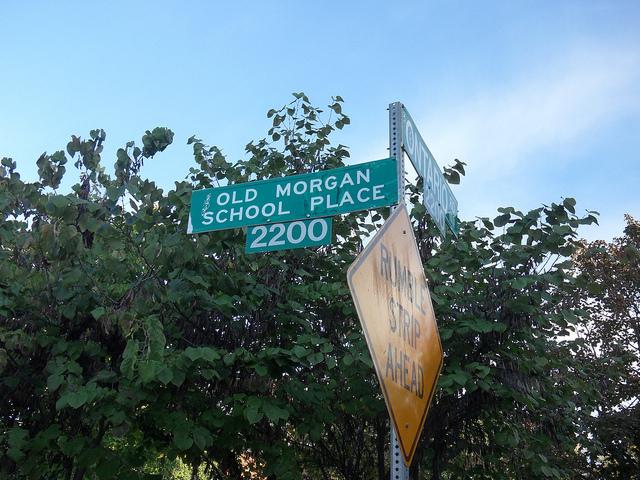What is behind the street sign?
Concise answer only. Tree. What is the name of this street?
Keep it brief. Old morgan school place. Where is the street sign?
Keep it brief. At top of pole. 